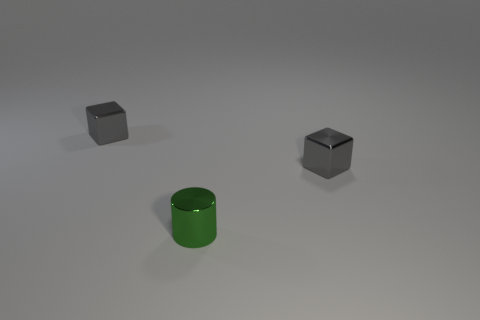Do the metal cylinder and the gray cube that is to the left of the green thing have the same size? While the gray cube and the metal cylinder appear to have similar dimensions, without knowing their exact measurements, one cannot confirm if they have the exact same size. However, based on the visible proportions in the image, they seem to be very close in size. 